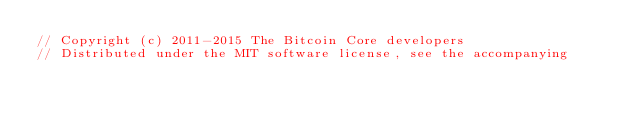Convert code to text. <code><loc_0><loc_0><loc_500><loc_500><_C++_>// Copyright (c) 2011-2015 The Bitcoin Core developers
// Distributed under the MIT software license, see the accompanying</code> 